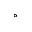Convert formula to latex. <formula><loc_0><loc_0><loc_500><loc_500>^ { \circ }</formula> 